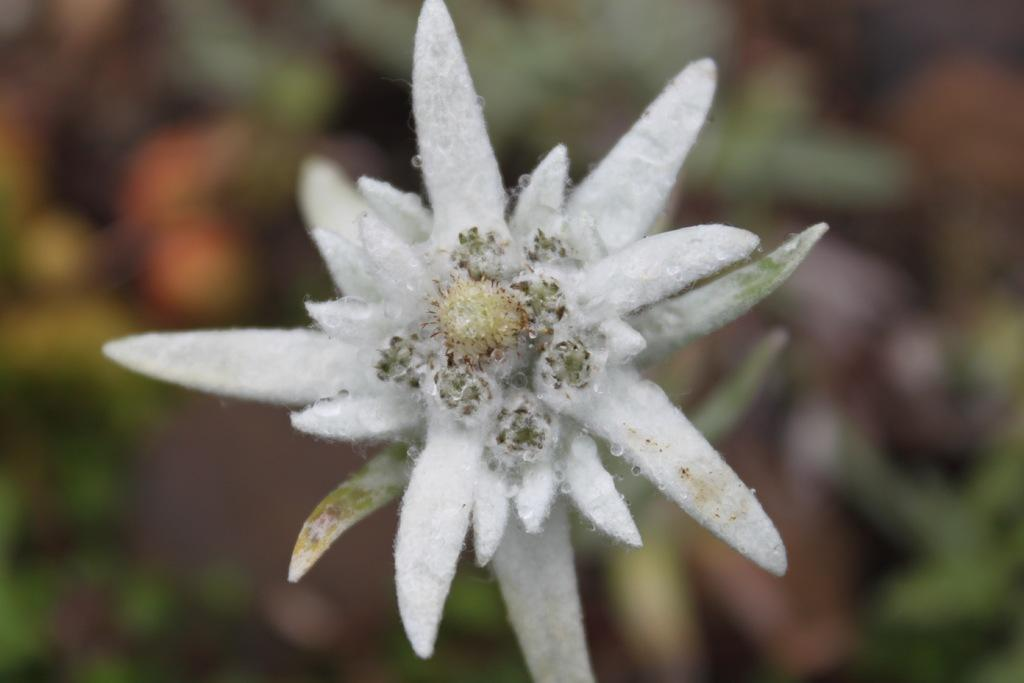What is the main subject of the image? There is a flower in the image. Can you describe the background of the image? The background of the image is blurred. Is there any smoke coming from the flower in the image? No, there is no smoke present in the image. The image features a flower and a blurred background, but no smoke or other elements mentioned in the absurd topics. 